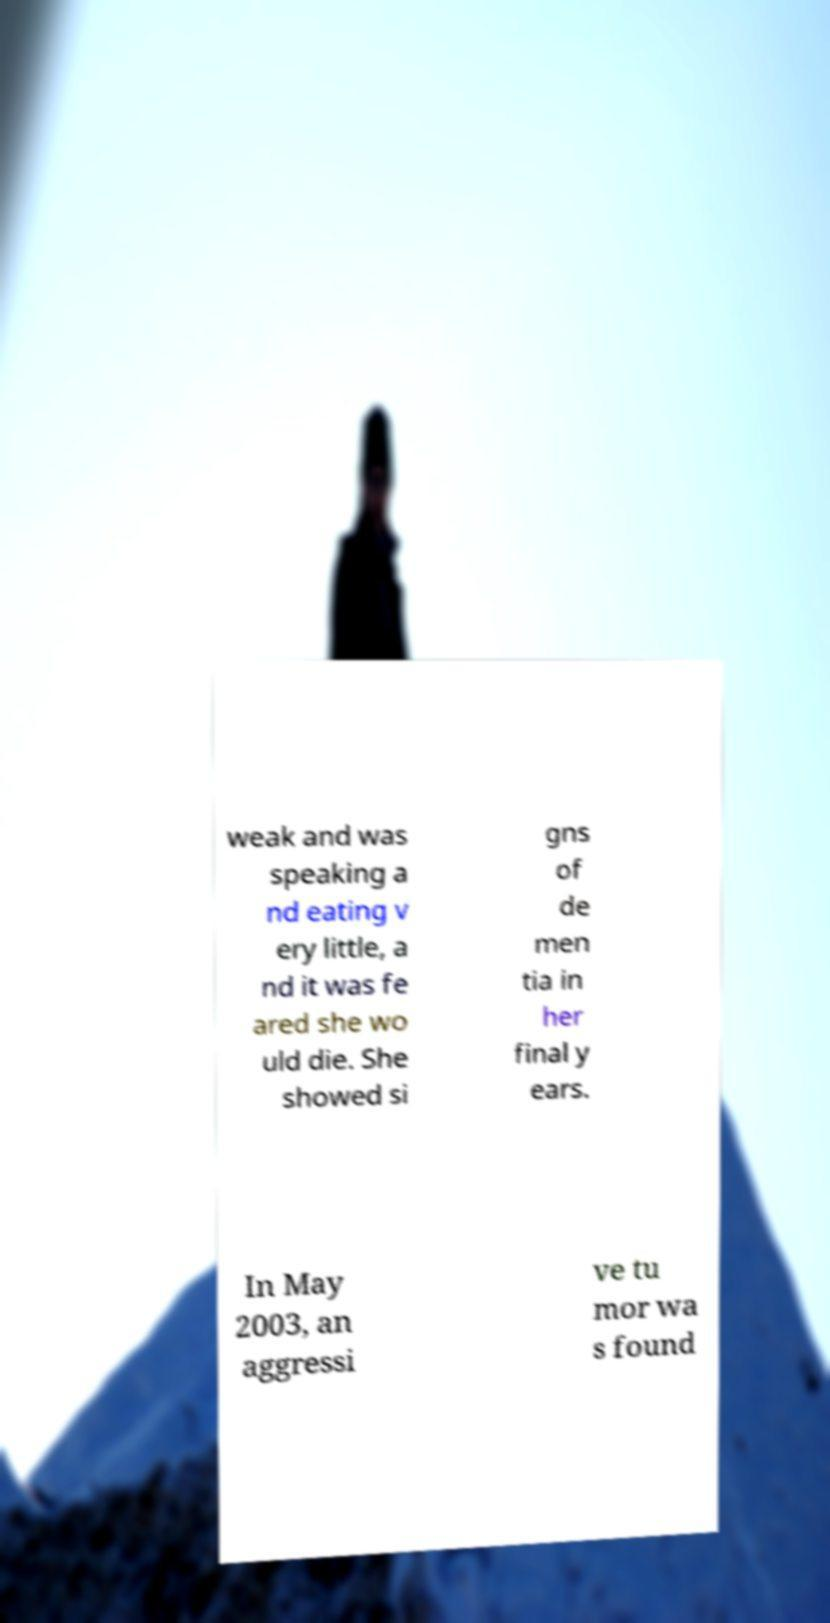Please read and relay the text visible in this image. What does it say? weak and was speaking a nd eating v ery little, a nd it was fe ared she wo uld die. She showed si gns of de men tia in her final y ears. In May 2003, an aggressi ve tu mor wa s found 